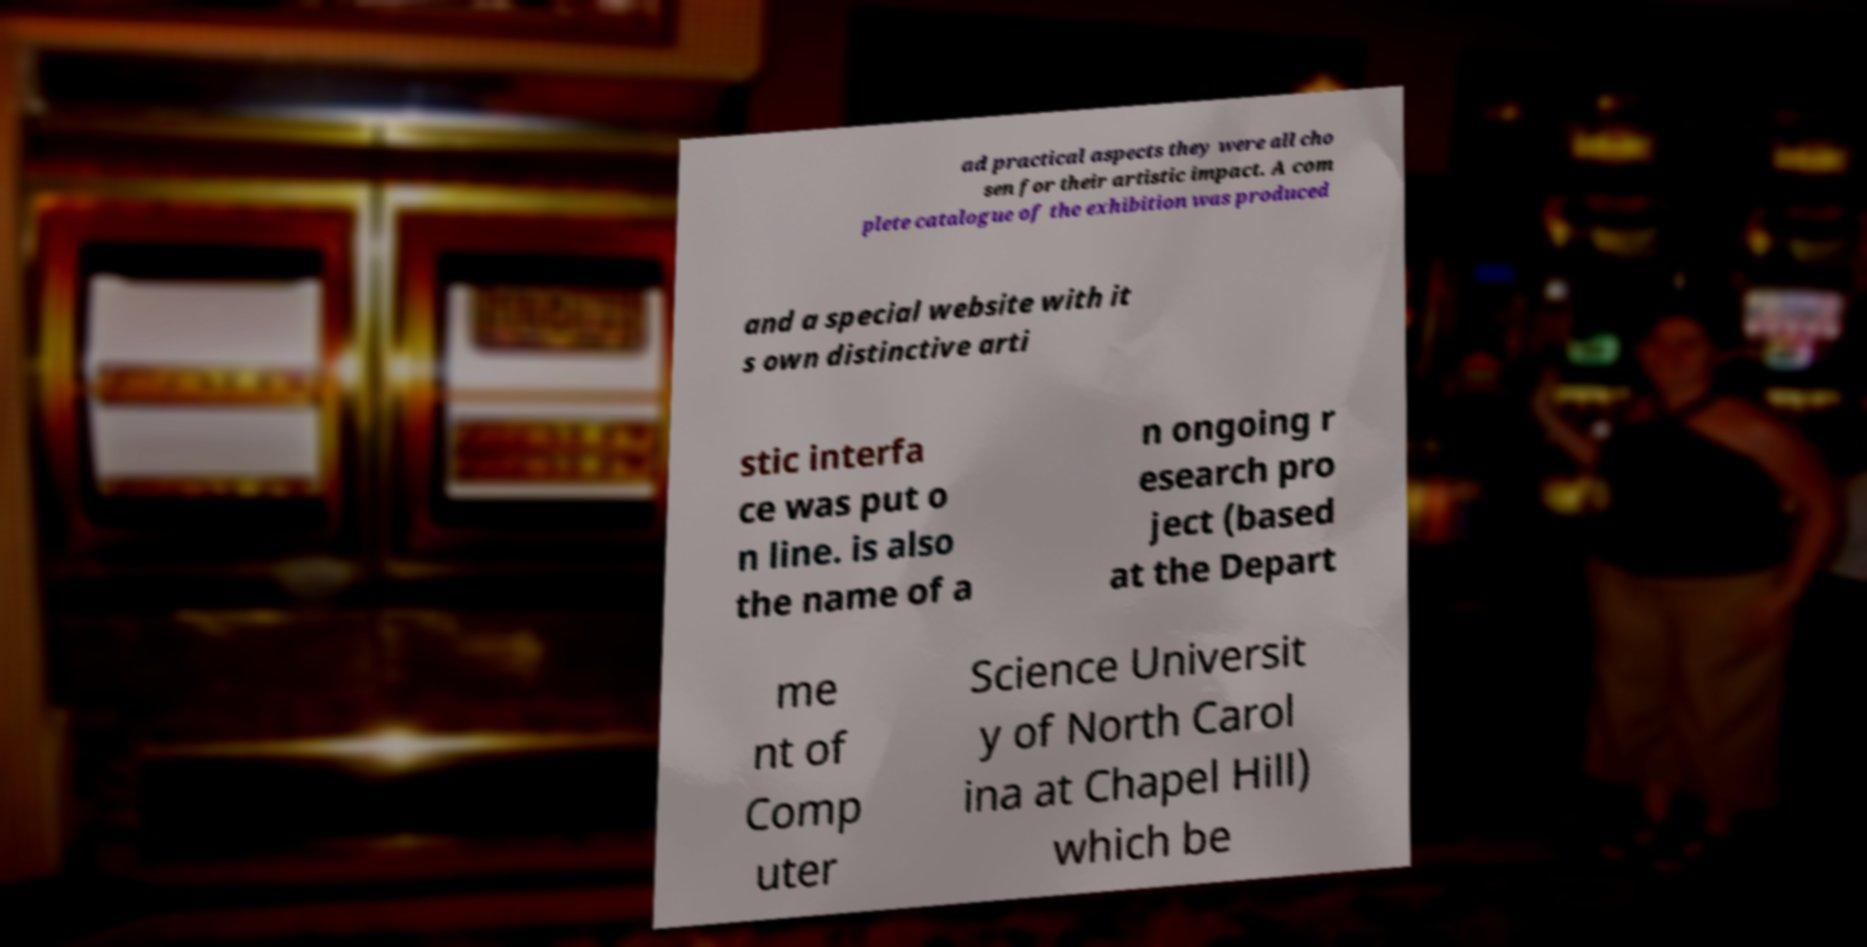Could you extract and type out the text from this image? ad practical aspects they were all cho sen for their artistic impact. A com plete catalogue of the exhibition was produced and a special website with it s own distinctive arti stic interfa ce was put o n line. is also the name of a n ongoing r esearch pro ject (based at the Depart me nt of Comp uter Science Universit y of North Carol ina at Chapel Hill) which be 